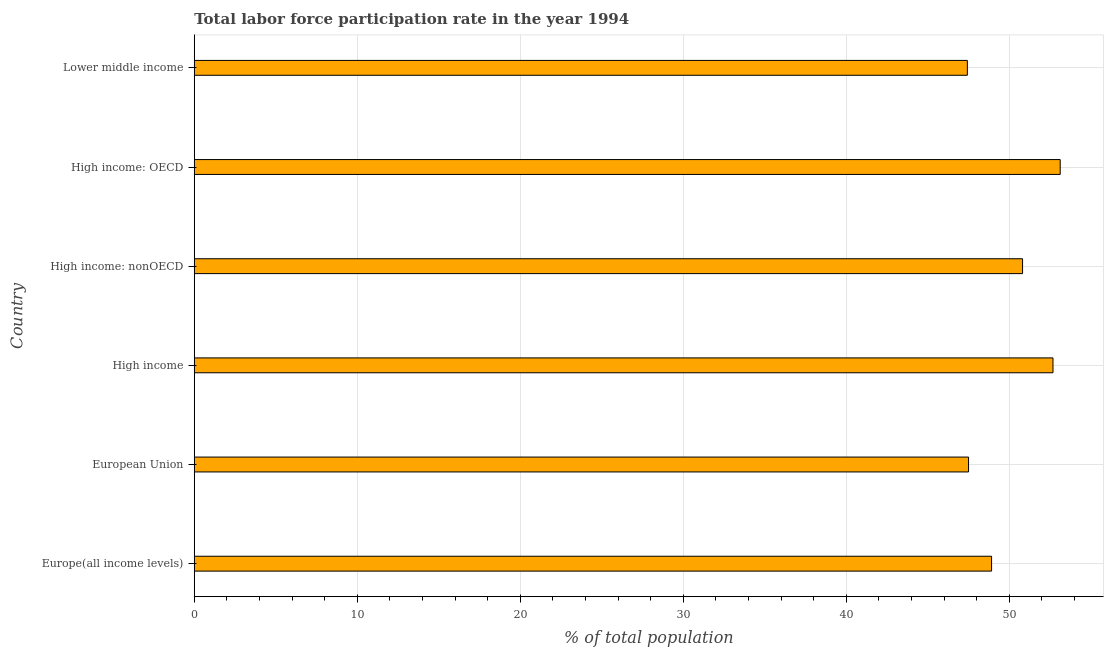Does the graph contain grids?
Offer a very short reply. Yes. What is the title of the graph?
Your answer should be compact. Total labor force participation rate in the year 1994. What is the label or title of the X-axis?
Ensure brevity in your answer.  % of total population. What is the total labor force participation rate in European Union?
Keep it short and to the point. 47.5. Across all countries, what is the maximum total labor force participation rate?
Provide a succinct answer. 53.12. Across all countries, what is the minimum total labor force participation rate?
Provide a succinct answer. 47.43. In which country was the total labor force participation rate maximum?
Your answer should be compact. High income: OECD. In which country was the total labor force participation rate minimum?
Provide a short and direct response. Lower middle income. What is the sum of the total labor force participation rate?
Ensure brevity in your answer.  300.45. What is the difference between the total labor force participation rate in Europe(all income levels) and European Union?
Give a very brief answer. 1.41. What is the average total labor force participation rate per country?
Offer a very short reply. 50.08. What is the median total labor force participation rate?
Keep it short and to the point. 49.86. In how many countries, is the total labor force participation rate greater than 30 %?
Provide a succinct answer. 6. What is the ratio of the total labor force participation rate in Europe(all income levels) to that in High income: nonOECD?
Keep it short and to the point. 0.96. Is the total labor force participation rate in Europe(all income levels) less than that in European Union?
Make the answer very short. No. What is the difference between the highest and the second highest total labor force participation rate?
Offer a terse response. 0.44. Is the sum of the total labor force participation rate in Europe(all income levels) and High income: OECD greater than the maximum total labor force participation rate across all countries?
Ensure brevity in your answer.  Yes. What is the difference between the highest and the lowest total labor force participation rate?
Provide a succinct answer. 5.69. How many bars are there?
Provide a short and direct response. 6. Are all the bars in the graph horizontal?
Make the answer very short. Yes. What is the difference between two consecutive major ticks on the X-axis?
Your answer should be compact. 10. What is the % of total population of Europe(all income levels)?
Your answer should be compact. 48.91. What is the % of total population of European Union?
Keep it short and to the point. 47.5. What is the % of total population in High income?
Provide a short and direct response. 52.68. What is the % of total population in High income: nonOECD?
Your answer should be compact. 50.81. What is the % of total population in High income: OECD?
Your answer should be very brief. 53.12. What is the % of total population in Lower middle income?
Keep it short and to the point. 47.43. What is the difference between the % of total population in Europe(all income levels) and European Union?
Offer a terse response. 1.41. What is the difference between the % of total population in Europe(all income levels) and High income?
Offer a terse response. -3.77. What is the difference between the % of total population in Europe(all income levels) and High income: nonOECD?
Your answer should be compact. -1.9. What is the difference between the % of total population in Europe(all income levels) and High income: OECD?
Your answer should be very brief. -4.21. What is the difference between the % of total population in Europe(all income levels) and Lower middle income?
Provide a short and direct response. 1.49. What is the difference between the % of total population in European Union and High income?
Offer a very short reply. -5.18. What is the difference between the % of total population in European Union and High income: nonOECD?
Your answer should be very brief. -3.31. What is the difference between the % of total population in European Union and High income: OECD?
Keep it short and to the point. -5.62. What is the difference between the % of total population in European Union and Lower middle income?
Your response must be concise. 0.07. What is the difference between the % of total population in High income and High income: nonOECD?
Make the answer very short. 1.87. What is the difference between the % of total population in High income and High income: OECD?
Provide a short and direct response. -0.44. What is the difference between the % of total population in High income and Lower middle income?
Provide a short and direct response. 5.25. What is the difference between the % of total population in High income: nonOECD and High income: OECD?
Your answer should be very brief. -2.31. What is the difference between the % of total population in High income: nonOECD and Lower middle income?
Provide a short and direct response. 3.39. What is the difference between the % of total population in High income: OECD and Lower middle income?
Your answer should be compact. 5.69. What is the ratio of the % of total population in Europe(all income levels) to that in High income?
Keep it short and to the point. 0.93. What is the ratio of the % of total population in Europe(all income levels) to that in High income: nonOECD?
Your response must be concise. 0.96. What is the ratio of the % of total population in Europe(all income levels) to that in High income: OECD?
Your answer should be compact. 0.92. What is the ratio of the % of total population in Europe(all income levels) to that in Lower middle income?
Keep it short and to the point. 1.03. What is the ratio of the % of total population in European Union to that in High income?
Offer a very short reply. 0.9. What is the ratio of the % of total population in European Union to that in High income: nonOECD?
Give a very brief answer. 0.94. What is the ratio of the % of total population in European Union to that in High income: OECD?
Give a very brief answer. 0.89. What is the ratio of the % of total population in High income to that in High income: nonOECD?
Make the answer very short. 1.04. What is the ratio of the % of total population in High income to that in Lower middle income?
Provide a short and direct response. 1.11. What is the ratio of the % of total population in High income: nonOECD to that in High income: OECD?
Offer a very short reply. 0.96. What is the ratio of the % of total population in High income: nonOECD to that in Lower middle income?
Give a very brief answer. 1.07. What is the ratio of the % of total population in High income: OECD to that in Lower middle income?
Offer a terse response. 1.12. 